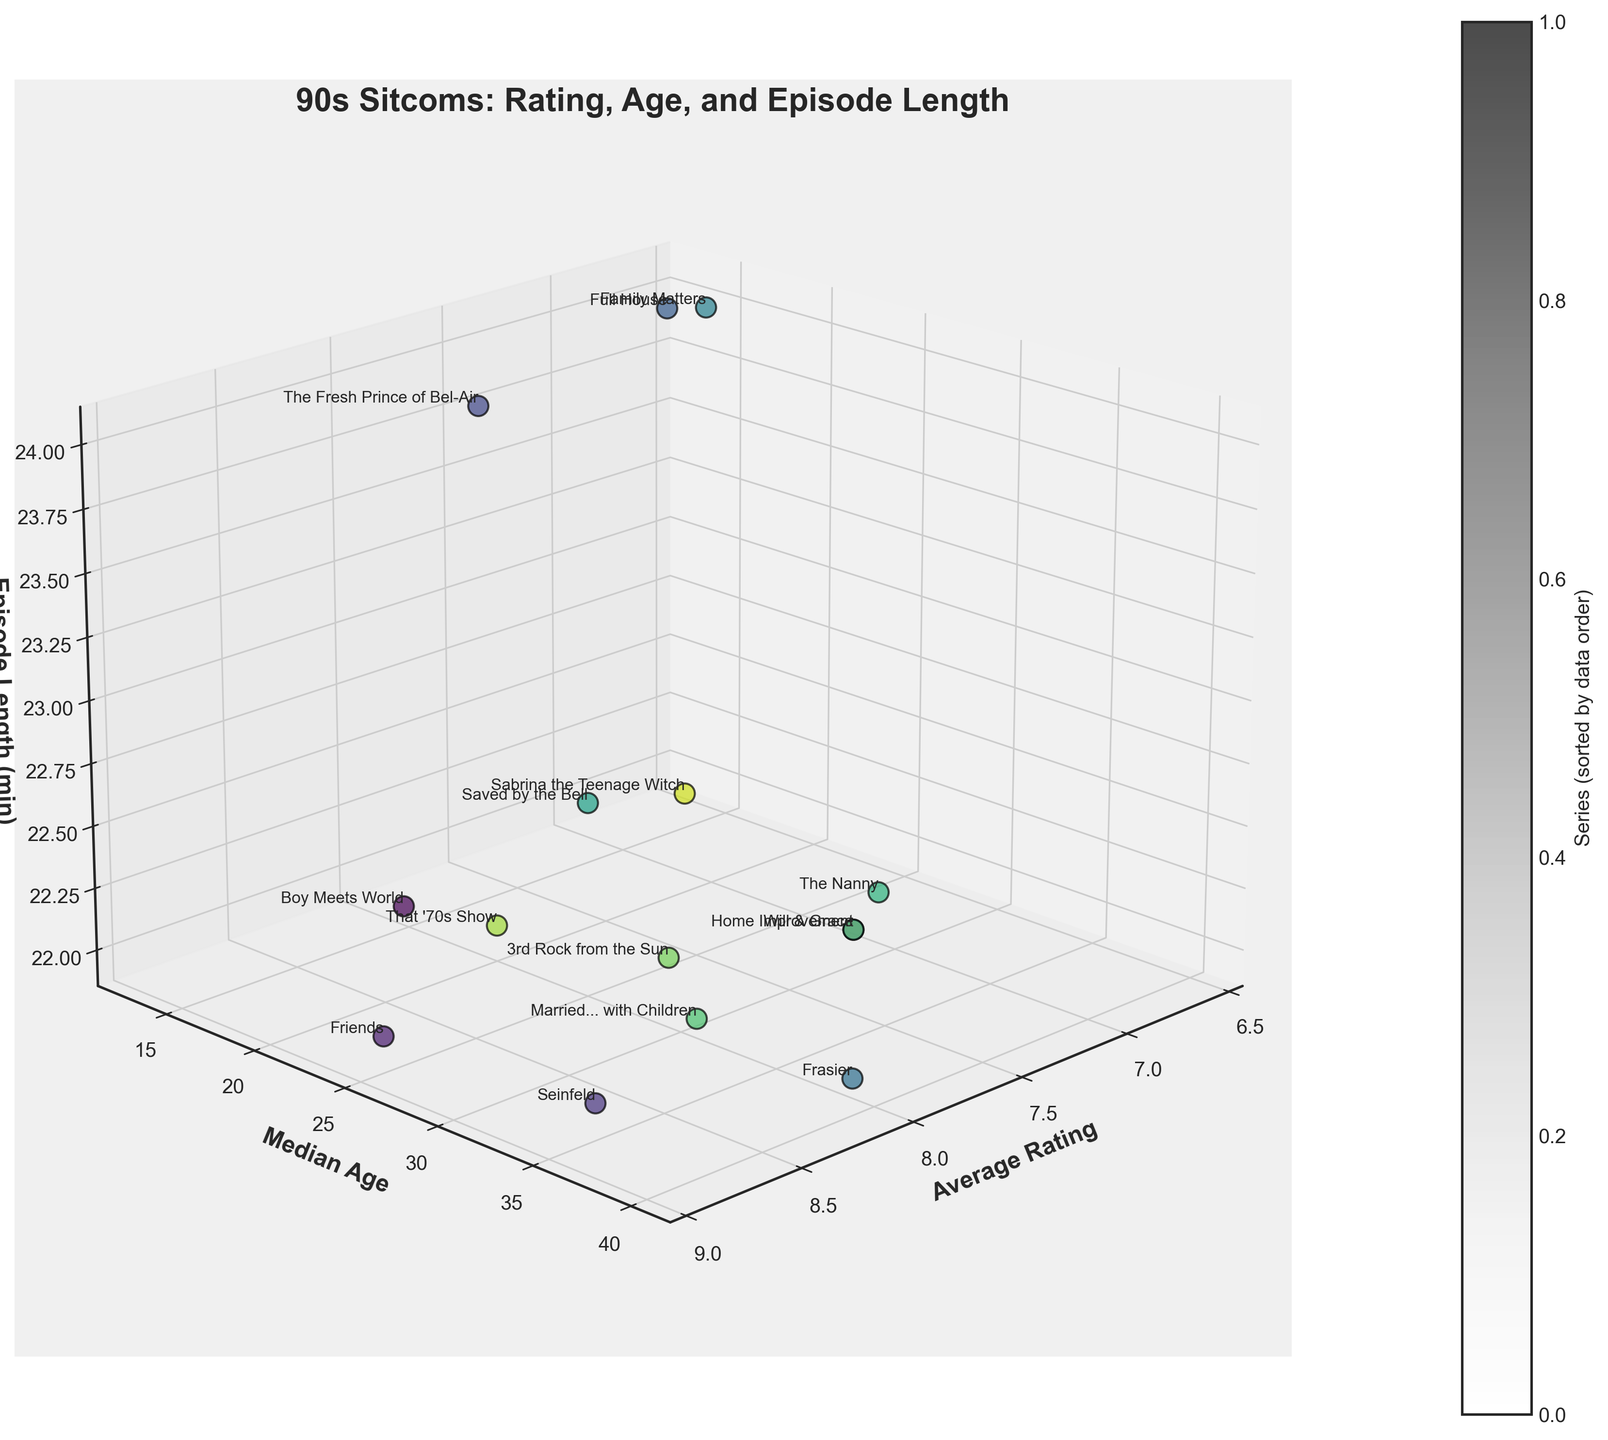What is the average rating of Seinfeld? The label next to Seinfeld will show its average rating.
Answer: 8.8 Which sitcom has the highest median age of viewers? Look at the sitcom with the highest y-value for the median age axis.
Answer: Frasier How many sitcoms have an episode length of 22 minutes? Count the number of data points at the 22-minute mark on the z-axis.
Answer: 11 Which sitcom has a lower rating: Full House or Family Matters? Compare the average ratings indicated by their labels.
Answer: Family Matters What are the median ages of viewers for Boy Meets World and Friends, and which is higher? Check the y-values next to Boy Meets World and Friends and compare them. Boy Meets World has 16 and Friends has 25.
Answer: Friends's median age is higher Which sitcom has the shortest episode length and what is its rating? Identify the sitcom at the lowest z-value and note its rating from the label.
Answer: The Fresh Prince of Bel-Air has a rating of 7.9 How does the viewer age of Full House compare to Saved by the Bell? Check the y-values for Full House and Saved by the Bell and compare them.
Answer: Full House has a higher median age Among the sitcoms with an average rating of 8.1, which one has the highest median age of viewers? Find the sitcoms with a rating of 8.1 on the x-axis and compare their y-values. Boy Meets World, Frasier, and Married... with Children have 16, 40, and 32 respectively, so Frasier has the highest median age.
Answer: Frasier What's the difference in viewer age between the youngest and oldest median age amongst the sitcoms? Subtract the lowest y-value (Saved by the Bell, 13) from the highest y-value (Frasier, 40).
Answer: 27 Which sitcom rated lower than 7.0 has the youngest viewers? Among the points with ratings below 7.0 on the x-axis, compare the y-values.
Answer: Saved by the Bell 